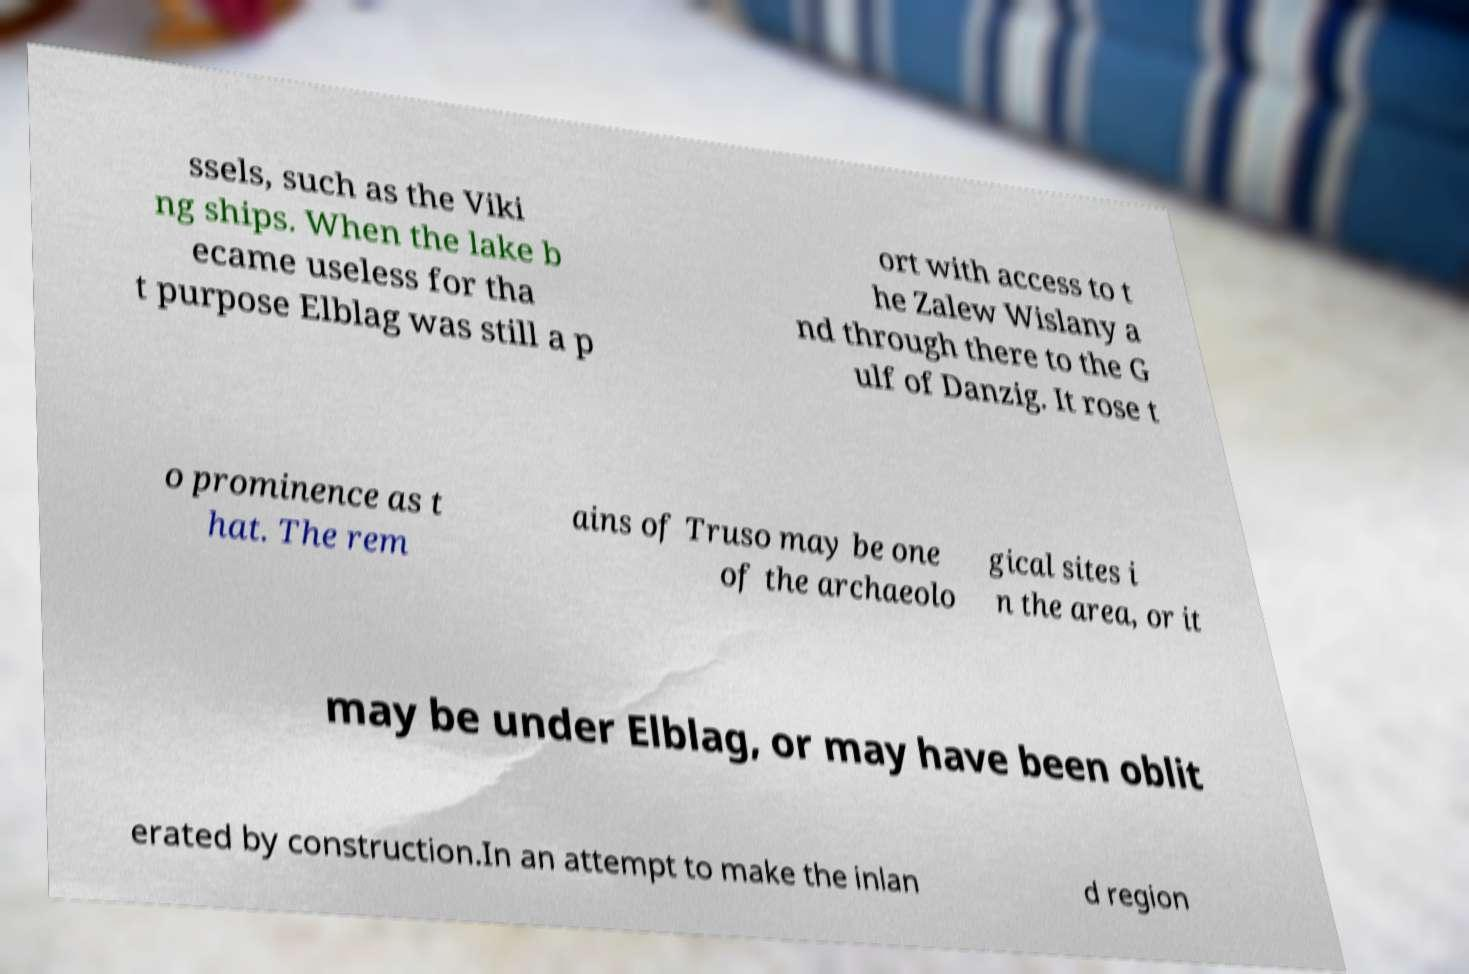Please identify and transcribe the text found in this image. ssels, such as the Viki ng ships. When the lake b ecame useless for tha t purpose Elblag was still a p ort with access to t he Zalew Wislany a nd through there to the G ulf of Danzig. It rose t o prominence as t hat. The rem ains of Truso may be one of the archaeolo gical sites i n the area, or it may be under Elblag, or may have been oblit erated by construction.In an attempt to make the inlan d region 